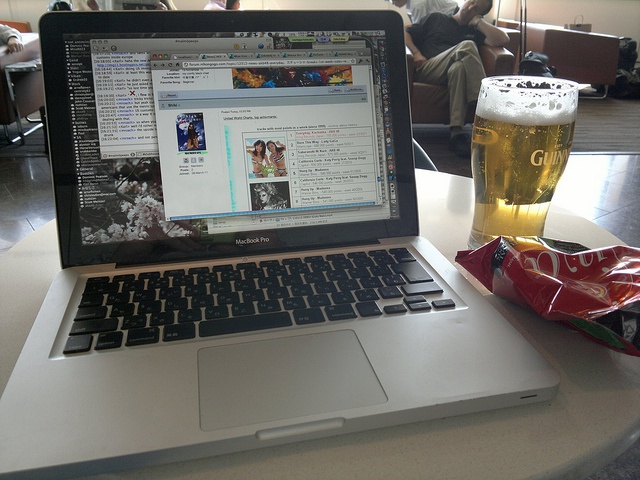Describe the objects in this image and their specific colors. I can see laptop in tan, black, darkgray, and gray tones, dining table in tan, gray, lightgray, black, and darkgray tones, cup in tan, olive, white, and gray tones, people in tan, black, gray, and darkgray tones, and couch in tan, black, gray, and white tones in this image. 